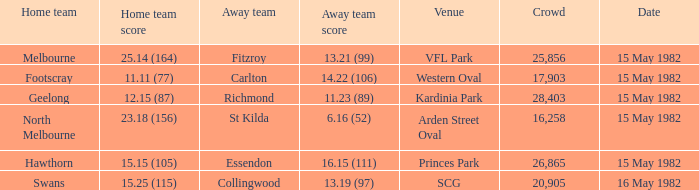Where did Geelong play as the home team? Kardinia Park. 